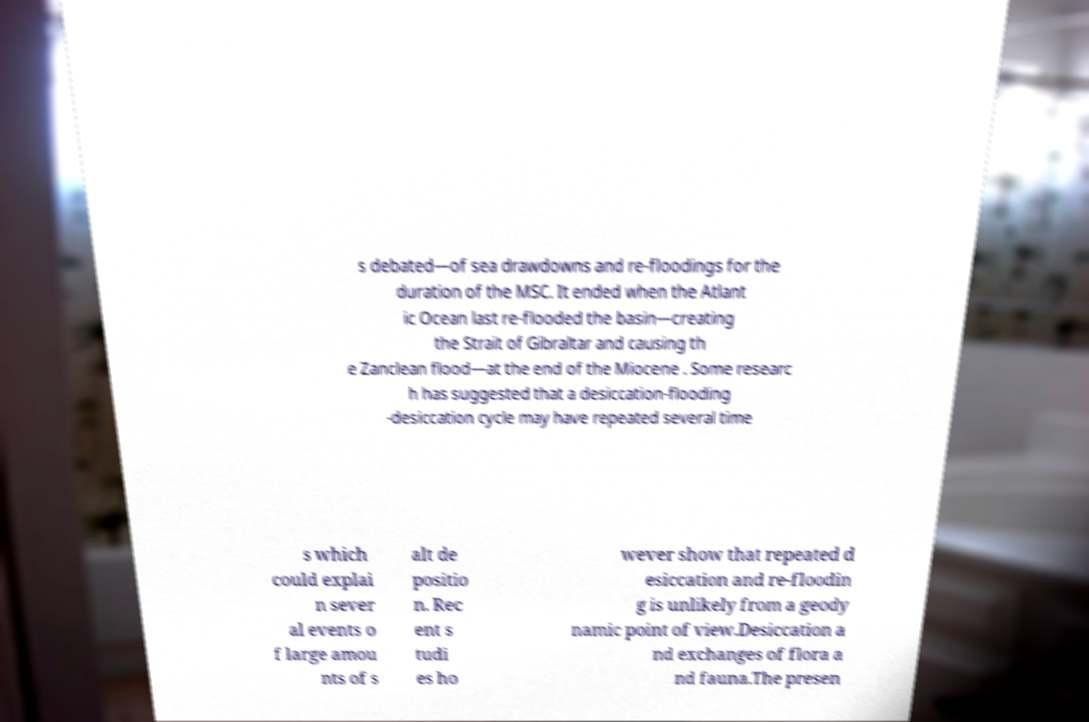For documentation purposes, I need the text within this image transcribed. Could you provide that? s debated—of sea drawdowns and re-floodings for the duration of the MSC. It ended when the Atlant ic Ocean last re-flooded the basin—creating the Strait of Gibraltar and causing th e Zanclean flood—at the end of the Miocene . Some researc h has suggested that a desiccation-flooding -desiccation cycle may have repeated several time s which could explai n sever al events o f large amou nts of s alt de positio n. Rec ent s tudi es ho wever show that repeated d esiccation and re-floodin g is unlikely from a geody namic point of view.Desiccation a nd exchanges of flora a nd fauna.The presen 